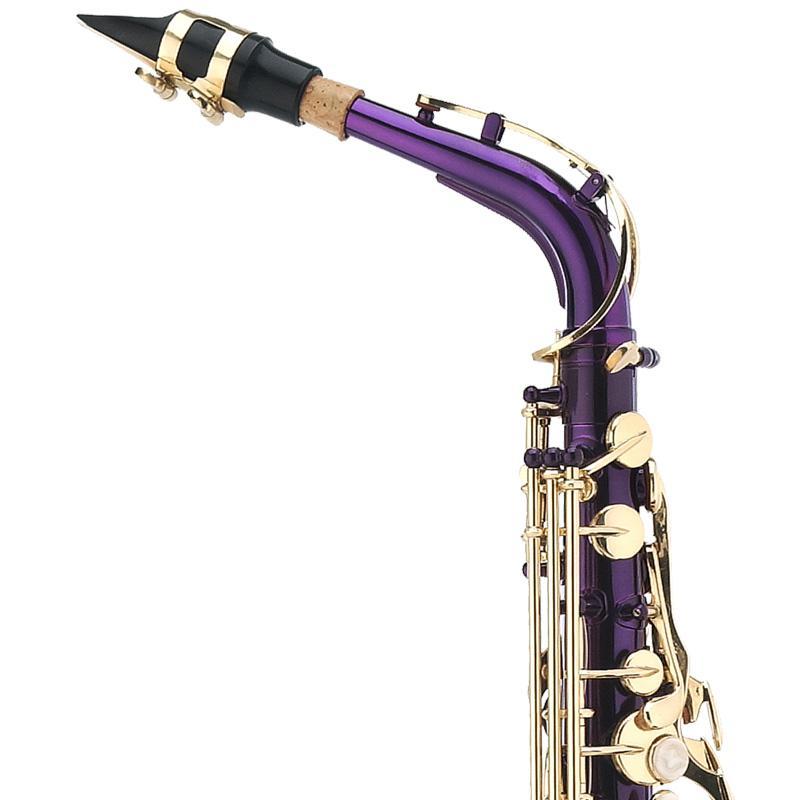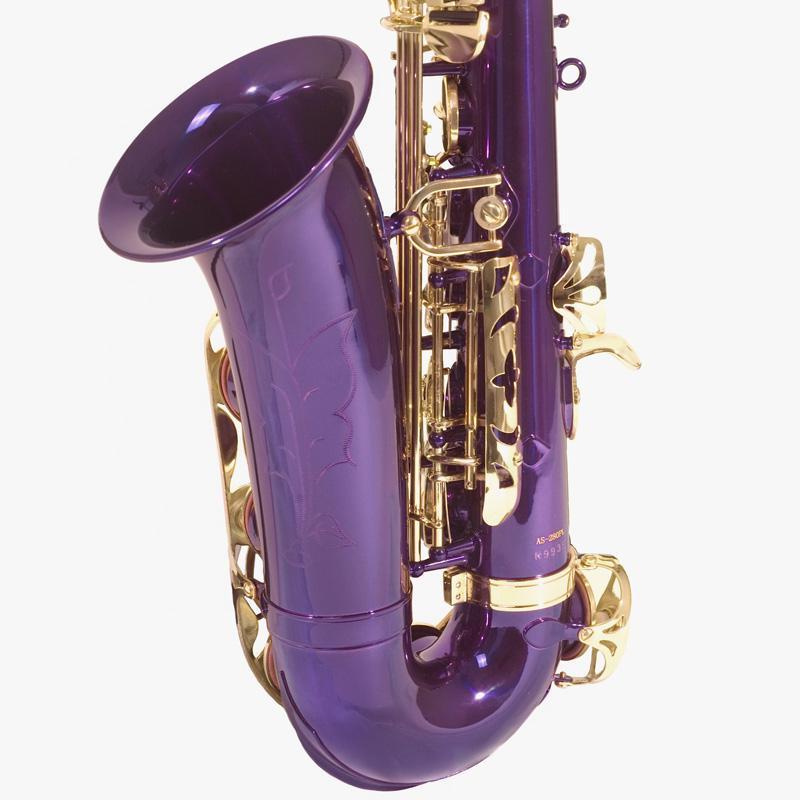The first image is the image on the left, the second image is the image on the right. For the images shown, is this caption "You can see an entire saxophone in both photos." true? Answer yes or no. No. 